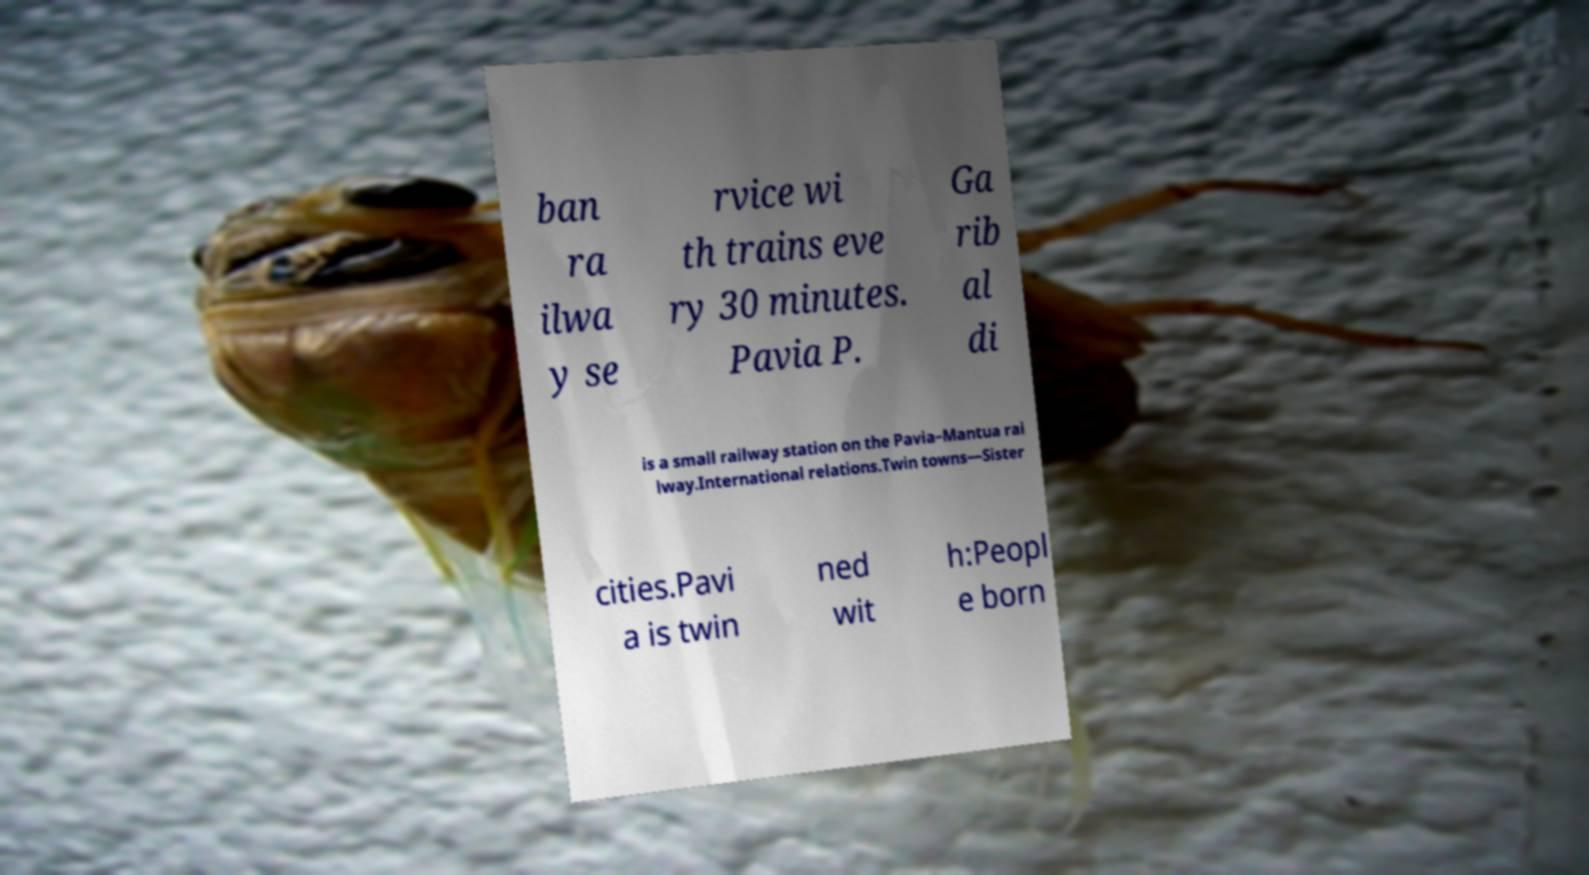What messages or text are displayed in this image? I need them in a readable, typed format. ban ra ilwa y se rvice wi th trains eve ry 30 minutes. Pavia P. Ga rib al di is a small railway station on the Pavia–Mantua rai lway.International relations.Twin towns—Sister cities.Pavi a is twin ned wit h:Peopl e born 